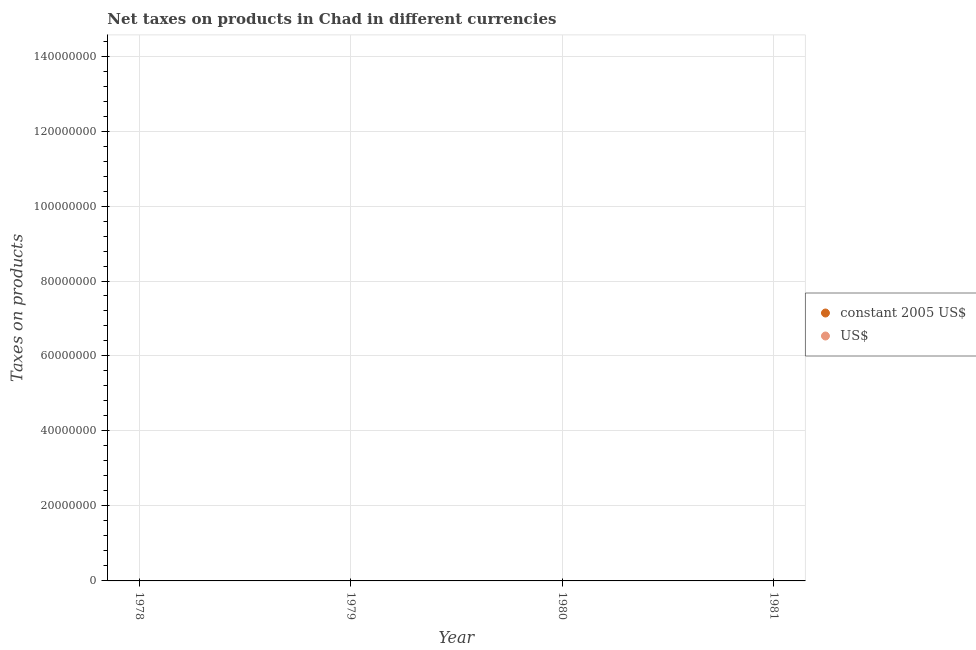How many different coloured dotlines are there?
Give a very brief answer. 0. What is the net taxes in us$ in 1979?
Make the answer very short. 0. What is the difference between the net taxes in constant 2005 us$ in 1981 and the net taxes in us$ in 1980?
Ensure brevity in your answer.  0. Does the net taxes in us$ monotonically increase over the years?
Offer a very short reply. No. Are the values on the major ticks of Y-axis written in scientific E-notation?
Your answer should be very brief. No. Where does the legend appear in the graph?
Your answer should be very brief. Center right. How are the legend labels stacked?
Your response must be concise. Vertical. What is the title of the graph?
Offer a terse response. Net taxes on products in Chad in different currencies. Does "Working only" appear as one of the legend labels in the graph?
Give a very brief answer. No. What is the label or title of the X-axis?
Offer a terse response. Year. What is the label or title of the Y-axis?
Your answer should be compact. Taxes on products. What is the Taxes on products of US$ in 1980?
Your answer should be very brief. 0. What is the Taxes on products in constant 2005 US$ in 1981?
Give a very brief answer. 0. What is the average Taxes on products of constant 2005 US$ per year?
Offer a very short reply. 0. 